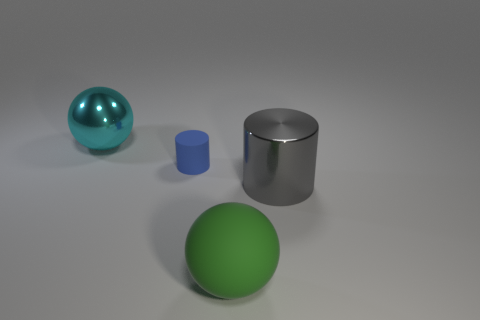What number of gray metal things are there?
Give a very brief answer. 1. Does the large gray cylinder have the same material as the cyan object?
Your answer should be very brief. Yes. What shape is the metallic object to the right of the tiny blue rubber thing left of the large shiny thing right of the big cyan thing?
Your answer should be compact. Cylinder. Do the big ball that is behind the tiny blue matte cylinder and the cylinder on the left side of the large green object have the same material?
Provide a short and direct response. No. What material is the tiny blue object?
Provide a short and direct response. Rubber. How many big green things are the same shape as the blue rubber thing?
Your answer should be compact. 0. There is a large metal object on the right side of the matte object to the left of the ball that is in front of the big metal cylinder; what color is it?
Provide a short and direct response. Gray. What number of large objects are either cyan metal things or cyan metal cubes?
Give a very brief answer. 1. Is the number of large shiny balls behind the big cyan ball the same as the number of tiny purple cubes?
Make the answer very short. Yes. Are there any blue matte cylinders in front of the blue matte thing?
Provide a succinct answer. No. 